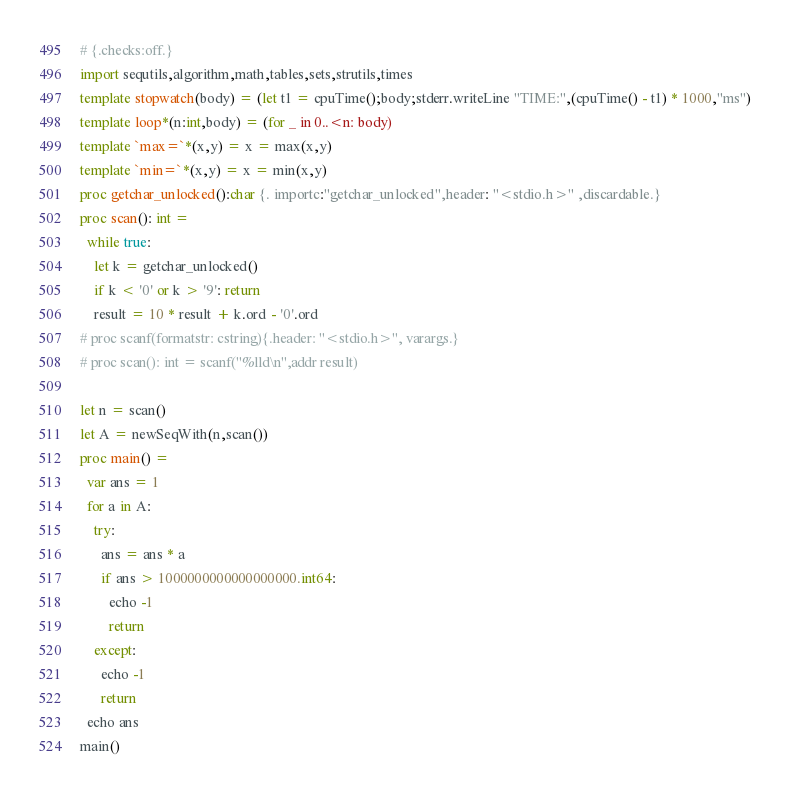<code> <loc_0><loc_0><loc_500><loc_500><_Nim_># {.checks:off.}
import sequtils,algorithm,math,tables,sets,strutils,times
template stopwatch(body) = (let t1 = cpuTime();body;stderr.writeLine "TIME:",(cpuTime() - t1) * 1000,"ms")
template loop*(n:int,body) = (for _ in 0..<n: body)
template `max=`*(x,y) = x = max(x,y)
template `min=`*(x,y) = x = min(x,y)
proc getchar_unlocked():char {. importc:"getchar_unlocked",header: "<stdio.h>" ,discardable.}
proc scan(): int =
  while true:
    let k = getchar_unlocked()
    if k < '0' or k > '9': return
    result = 10 * result + k.ord - '0'.ord
# proc scanf(formatstr: cstring){.header: "<stdio.h>", varargs.}
# proc scan(): int = scanf("%lld\n",addr result)

let n = scan()
let A = newSeqWith(n,scan())
proc main() =
  var ans = 1
  for a in A:
    try:
      ans = ans * a
      if ans > 1000000000000000000.int64:
        echo -1
        return
    except:
      echo -1
      return
  echo ans
main()
</code> 